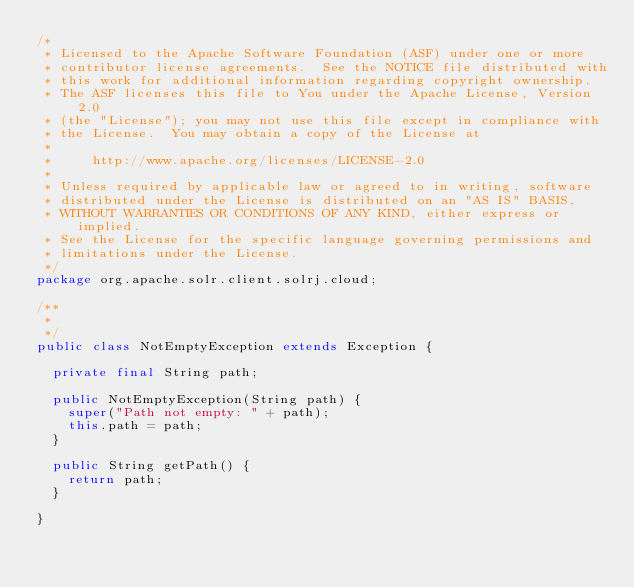Convert code to text. <code><loc_0><loc_0><loc_500><loc_500><_Java_>/*
 * Licensed to the Apache Software Foundation (ASF) under one or more
 * contributor license agreements.  See the NOTICE file distributed with
 * this work for additional information regarding copyright ownership.
 * The ASF licenses this file to You under the Apache License, Version 2.0
 * (the "License"); you may not use this file except in compliance with
 * the License.  You may obtain a copy of the License at
 *
 *     http://www.apache.org/licenses/LICENSE-2.0
 *
 * Unless required by applicable law or agreed to in writing, software
 * distributed under the License is distributed on an "AS IS" BASIS,
 * WITHOUT WARRANTIES OR CONDITIONS OF ANY KIND, either express or implied.
 * See the License for the specific language governing permissions and
 * limitations under the License.
 */
package org.apache.solr.client.solrj.cloud;

/**
 *
 */
public class NotEmptyException extends Exception {

  private final String path;

  public NotEmptyException(String path) {
    super("Path not empty: " + path);
    this.path = path;
  }

  public String getPath() {
    return path;
  }

}
</code> 